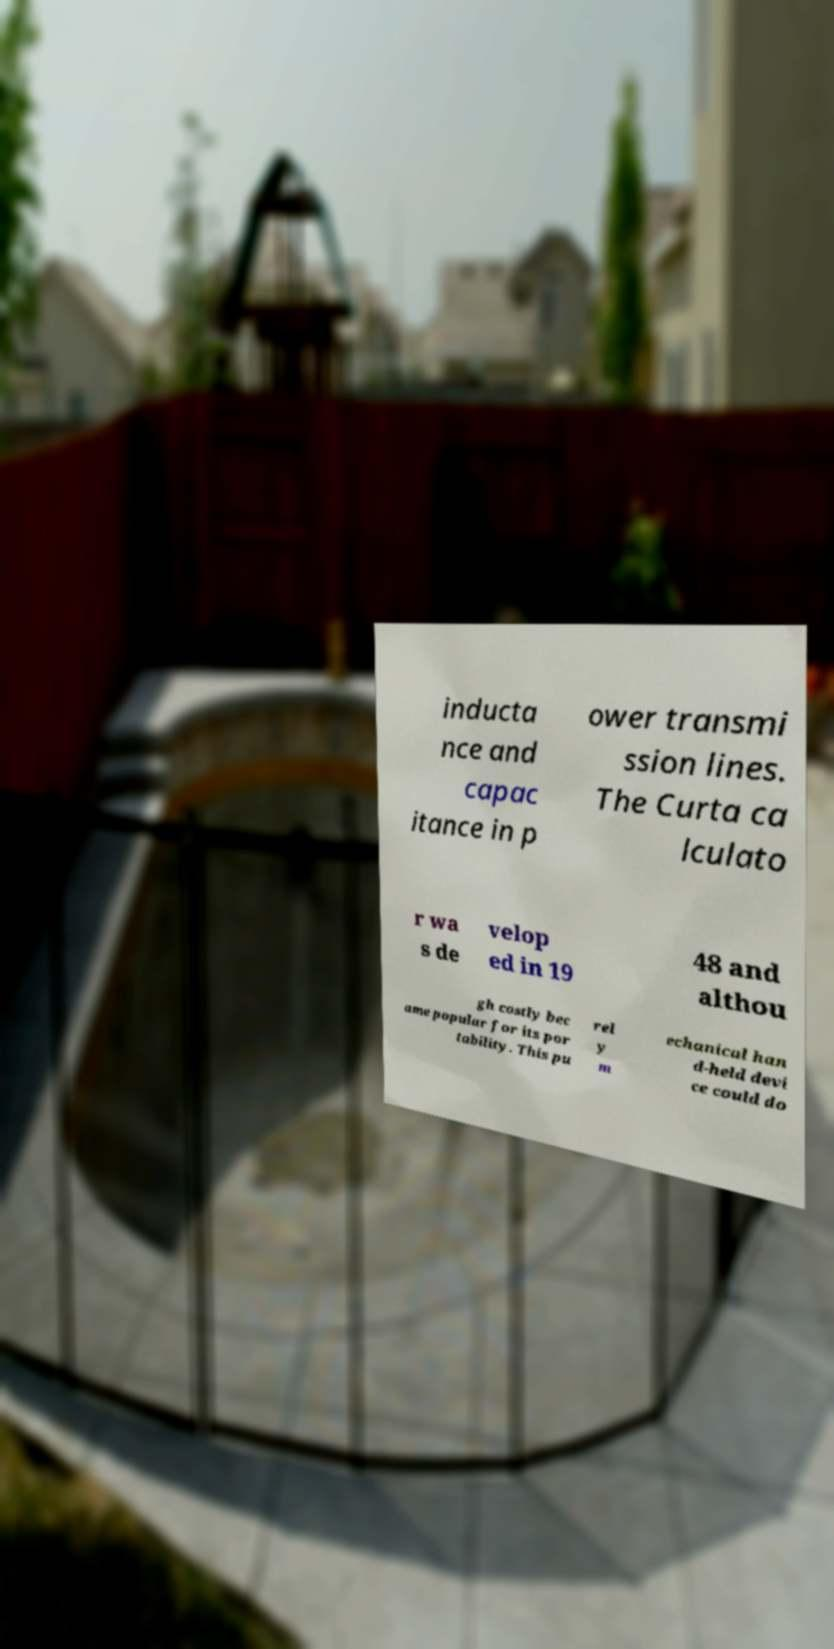Please read and relay the text visible in this image. What does it say? inducta nce and capac itance in p ower transmi ssion lines. The Curta ca lculato r wa s de velop ed in 19 48 and althou gh costly bec ame popular for its por tability. This pu rel y m echanical han d-held devi ce could do 